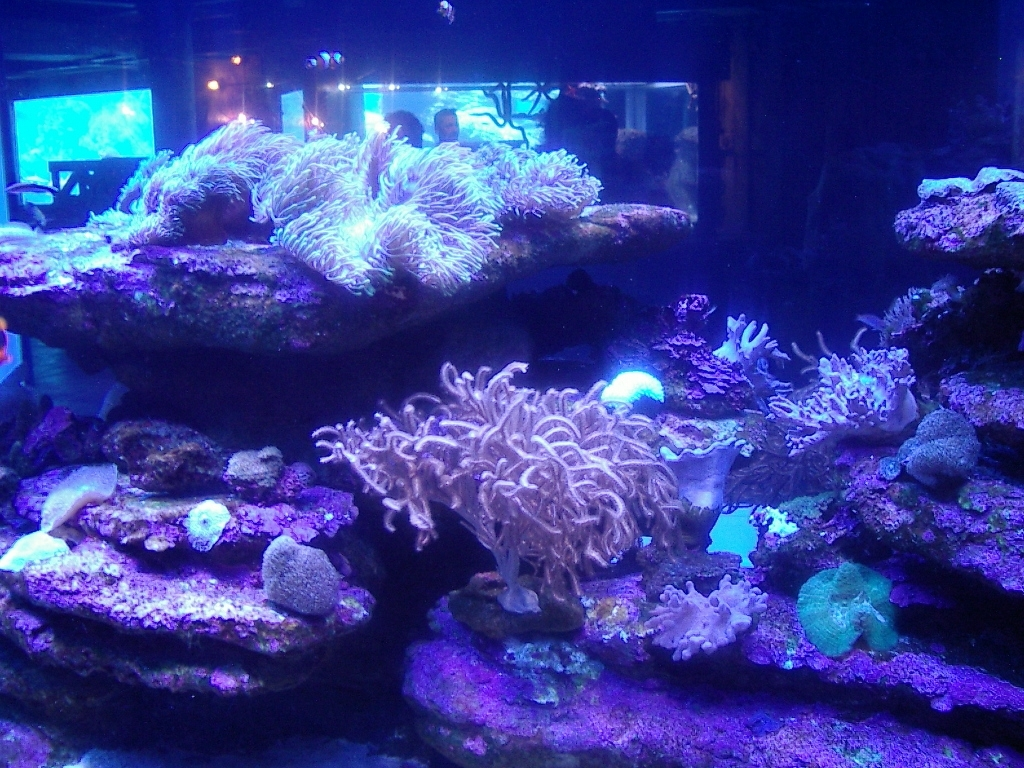How does the lighting in this image affect the appearance of the corals? The lighting in aquariums, especially when using actinic lights which emit blue light, can make corals appear more fluorescent and vibrant. This is because many corals contain proteins that react to blue light, resulting in a glowing effect. In this image, the lighting accentuates the colors and textures of the corals, giving them an ethereal appearance. 